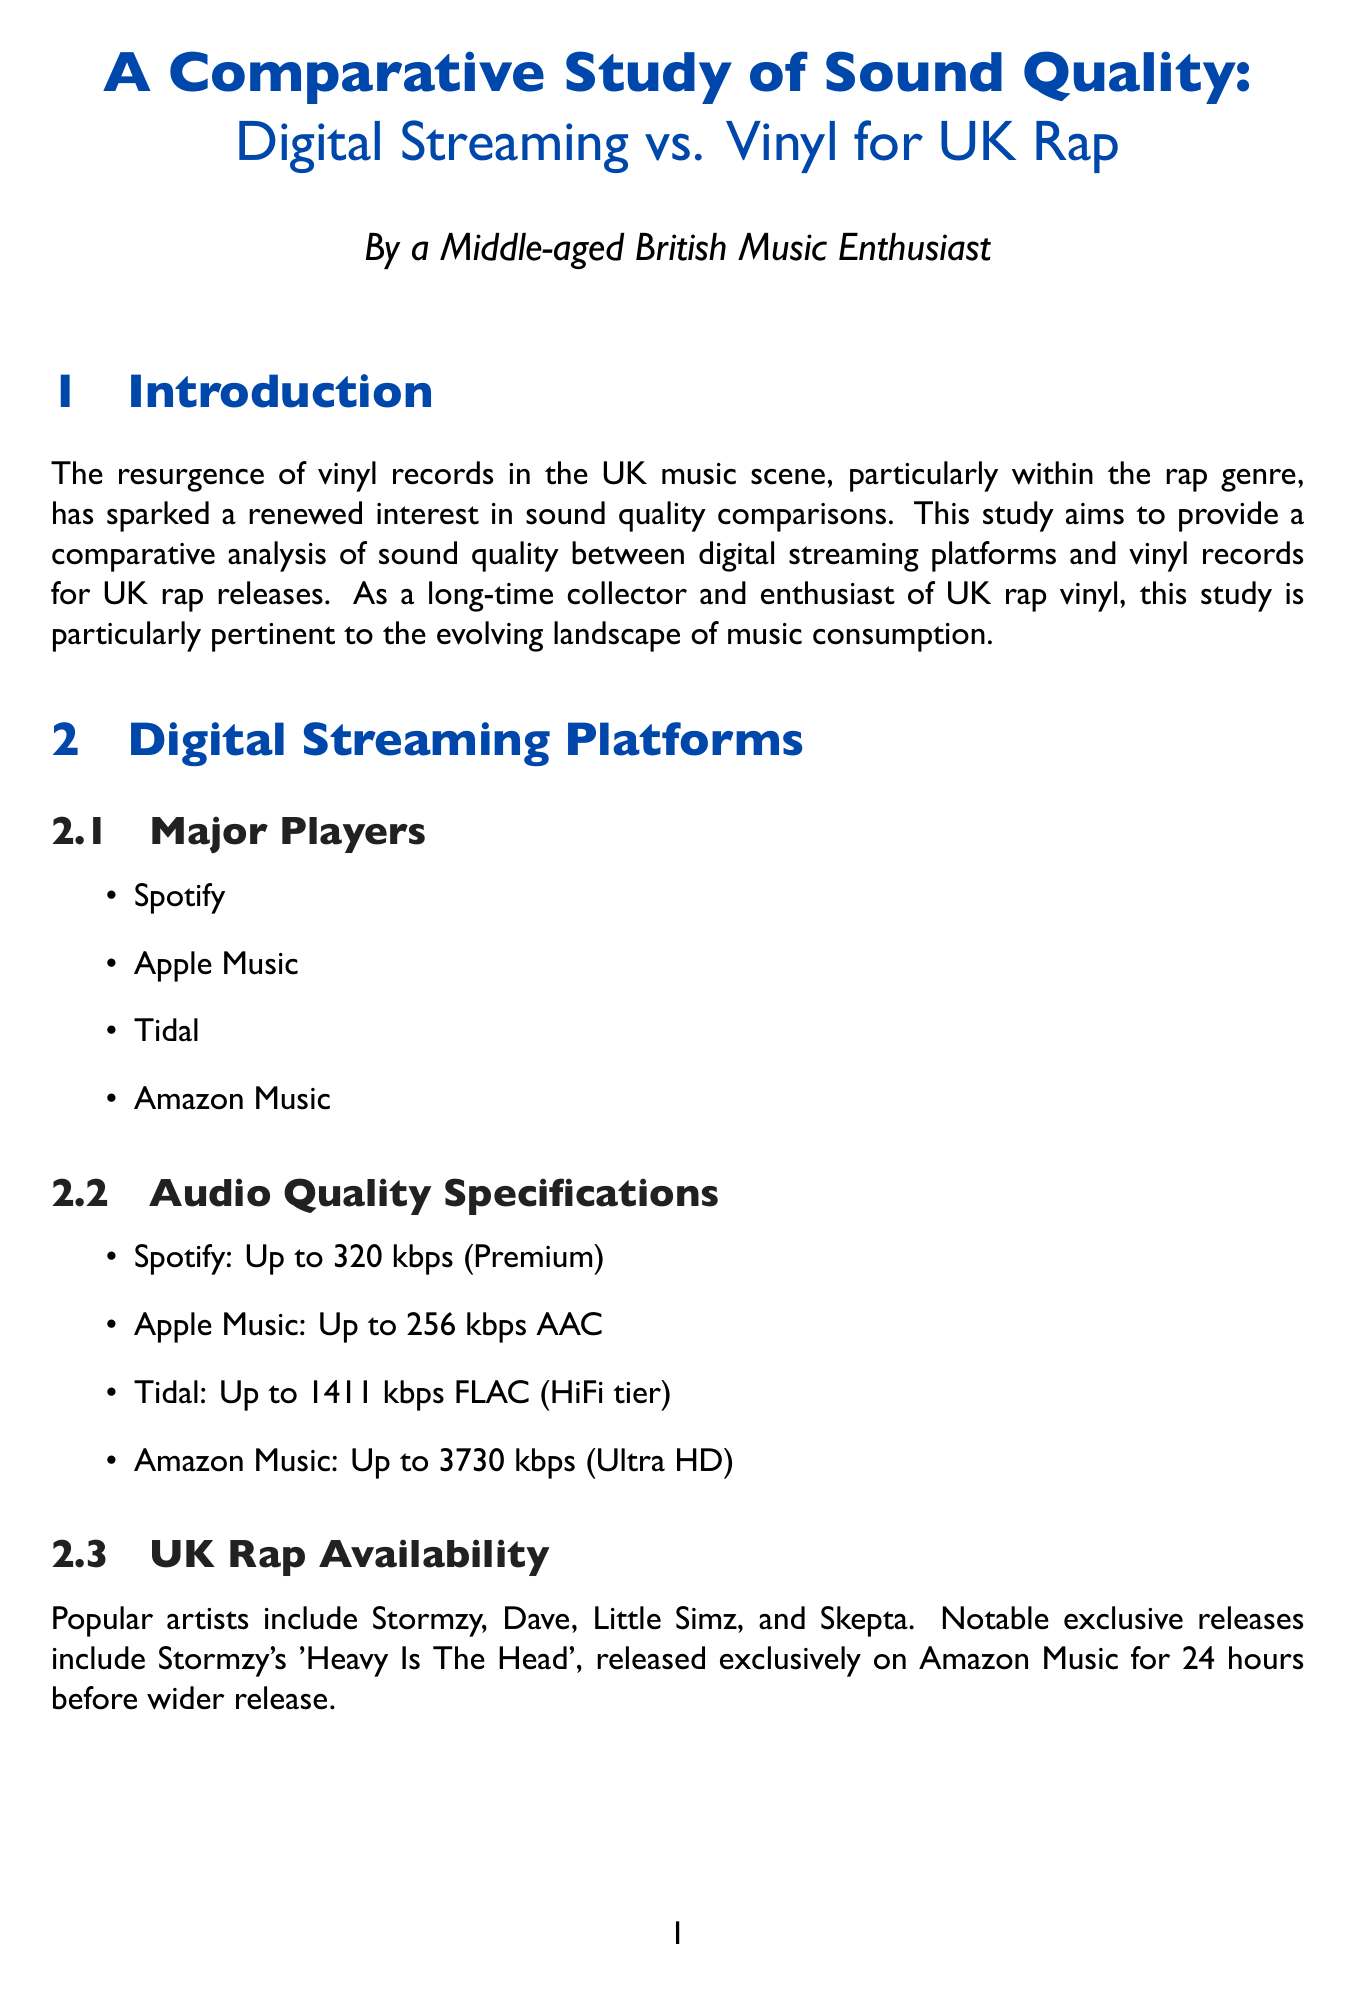What is the thesis of the study? The thesis outlines the main focus of the report, which is to analyze sound quality differences between digital streaming platforms and vinyl records for UK rap releases.
Answer: comparative analysis of sound quality between digital streaming platforms and vinyl records for UK rap releases Which streaming platform has the highest audio quality specification? The answer can be found in the audio quality specifications section, comparing the kilobits per second values.
Answer: Amazon Music What factor is NOT listed under pressing quality? The question requires identifying which factor does not belong to the listed elements regarding pressing quality.
Answer: Mastering techniques Name one popular UK rap artist available on digital streaming platforms. The question seeks an example from the list of artists found in the document.
Answer: Stormzy What year was Dizzee Rascal's album "Boy in da Corner" released? The document contains a list of classic albums with their release years, specifically referring to this album.
Answer: 2003 What subjective factor enhances the listener experience of vinyl? The question asks for a factor mentioned under listener experience which adds to the enjoyment of vinyl records.
Answer: Ritual of playing vinyl What is the primary method used to compare sound quality? This summarises the methodology section, outlining the approach taken to compare the sound quality.
Answer: Equipment Which album is used as a case study comparing Spotify Premium and 180g vinyl? The answer requires identifying a specific case study mentioned in the document related to a UK rap artist.
Answer: Landlord 